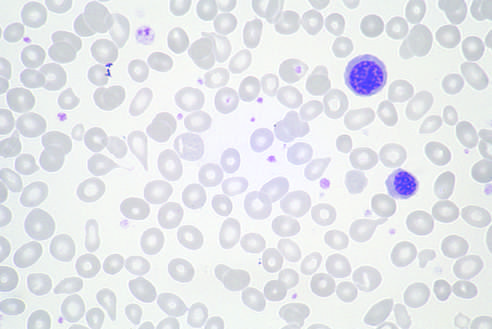were immature myeloid cells present in other fields?
Answer the question using a single word or phrase. Yes 